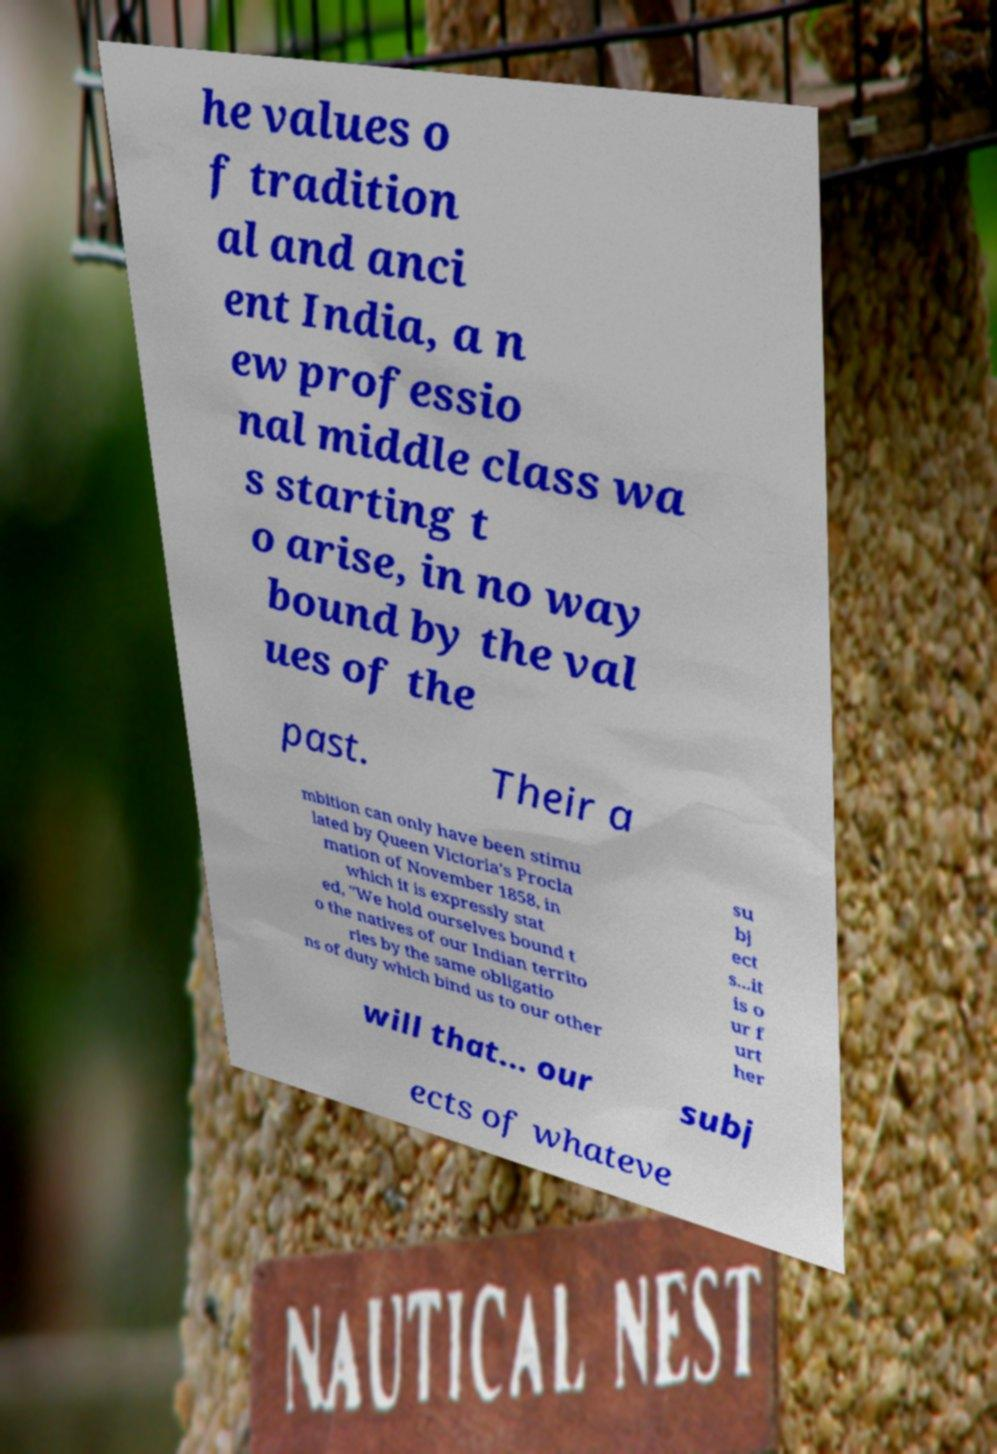Please read and relay the text visible in this image. What does it say? he values o f tradition al and anci ent India, a n ew professio nal middle class wa s starting t o arise, in no way bound by the val ues of the past. Their a mbition can only have been stimu lated by Queen Victoria's Procla mation of November 1858, in which it is expressly stat ed, "We hold ourselves bound t o the natives of our Indian territo ries by the same obligatio ns of duty which bind us to our other su bj ect s...it is o ur f urt her will that... our subj ects of whateve 